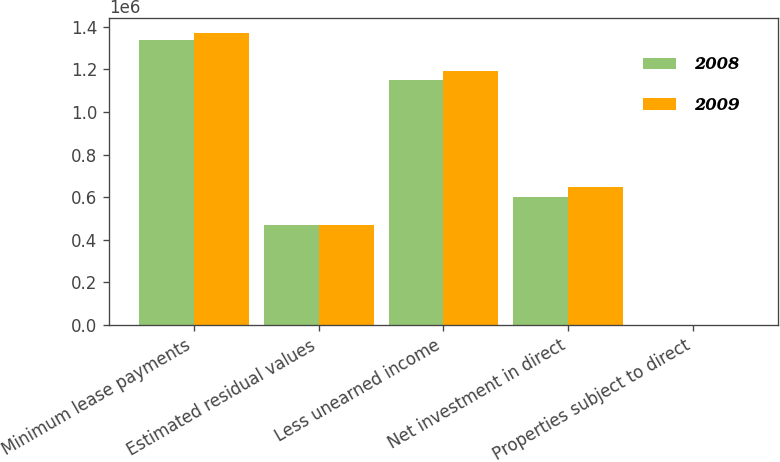Convert chart. <chart><loc_0><loc_0><loc_500><loc_500><stacked_bar_chart><ecel><fcel>Minimum lease payments<fcel>Estimated residual values<fcel>Less unearned income<fcel>Net investment in direct<fcel>Properties subject to direct<nl><fcel>2008<fcel>1.33863e+06<fcel>467248<fcel>1.15085e+06<fcel>600077<fcel>30<nl><fcel>2009<fcel>1.37328e+06<fcel>467248<fcel>1.1923e+06<fcel>648234<fcel>30<nl></chart> 